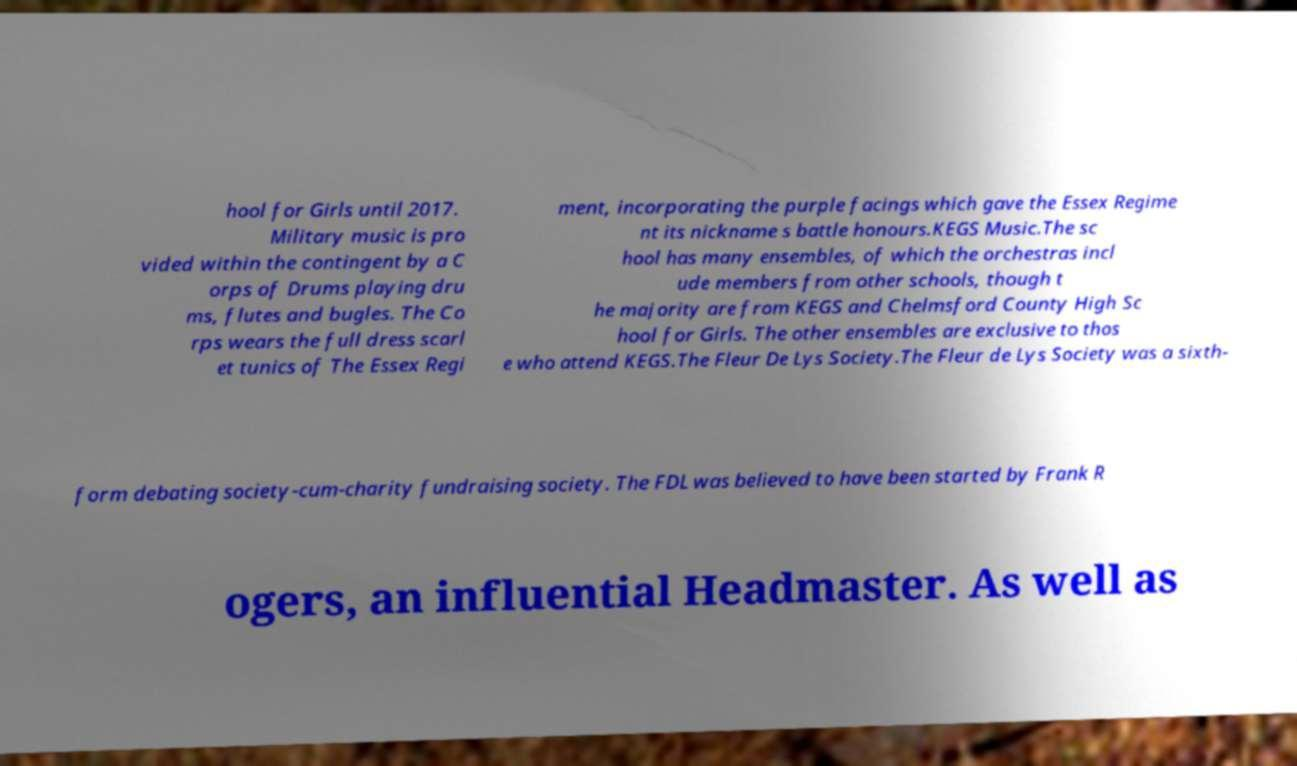Can you accurately transcribe the text from the provided image for me? hool for Girls until 2017. Military music is pro vided within the contingent by a C orps of Drums playing dru ms, flutes and bugles. The Co rps wears the full dress scarl et tunics of The Essex Regi ment, incorporating the purple facings which gave the Essex Regime nt its nickname s battle honours.KEGS Music.The sc hool has many ensembles, of which the orchestras incl ude members from other schools, though t he majority are from KEGS and Chelmsford County High Sc hool for Girls. The other ensembles are exclusive to thos e who attend KEGS.The Fleur De Lys Society.The Fleur de Lys Society was a sixth- form debating society-cum-charity fundraising society. The FDL was believed to have been started by Frank R ogers, an influential Headmaster. As well as 